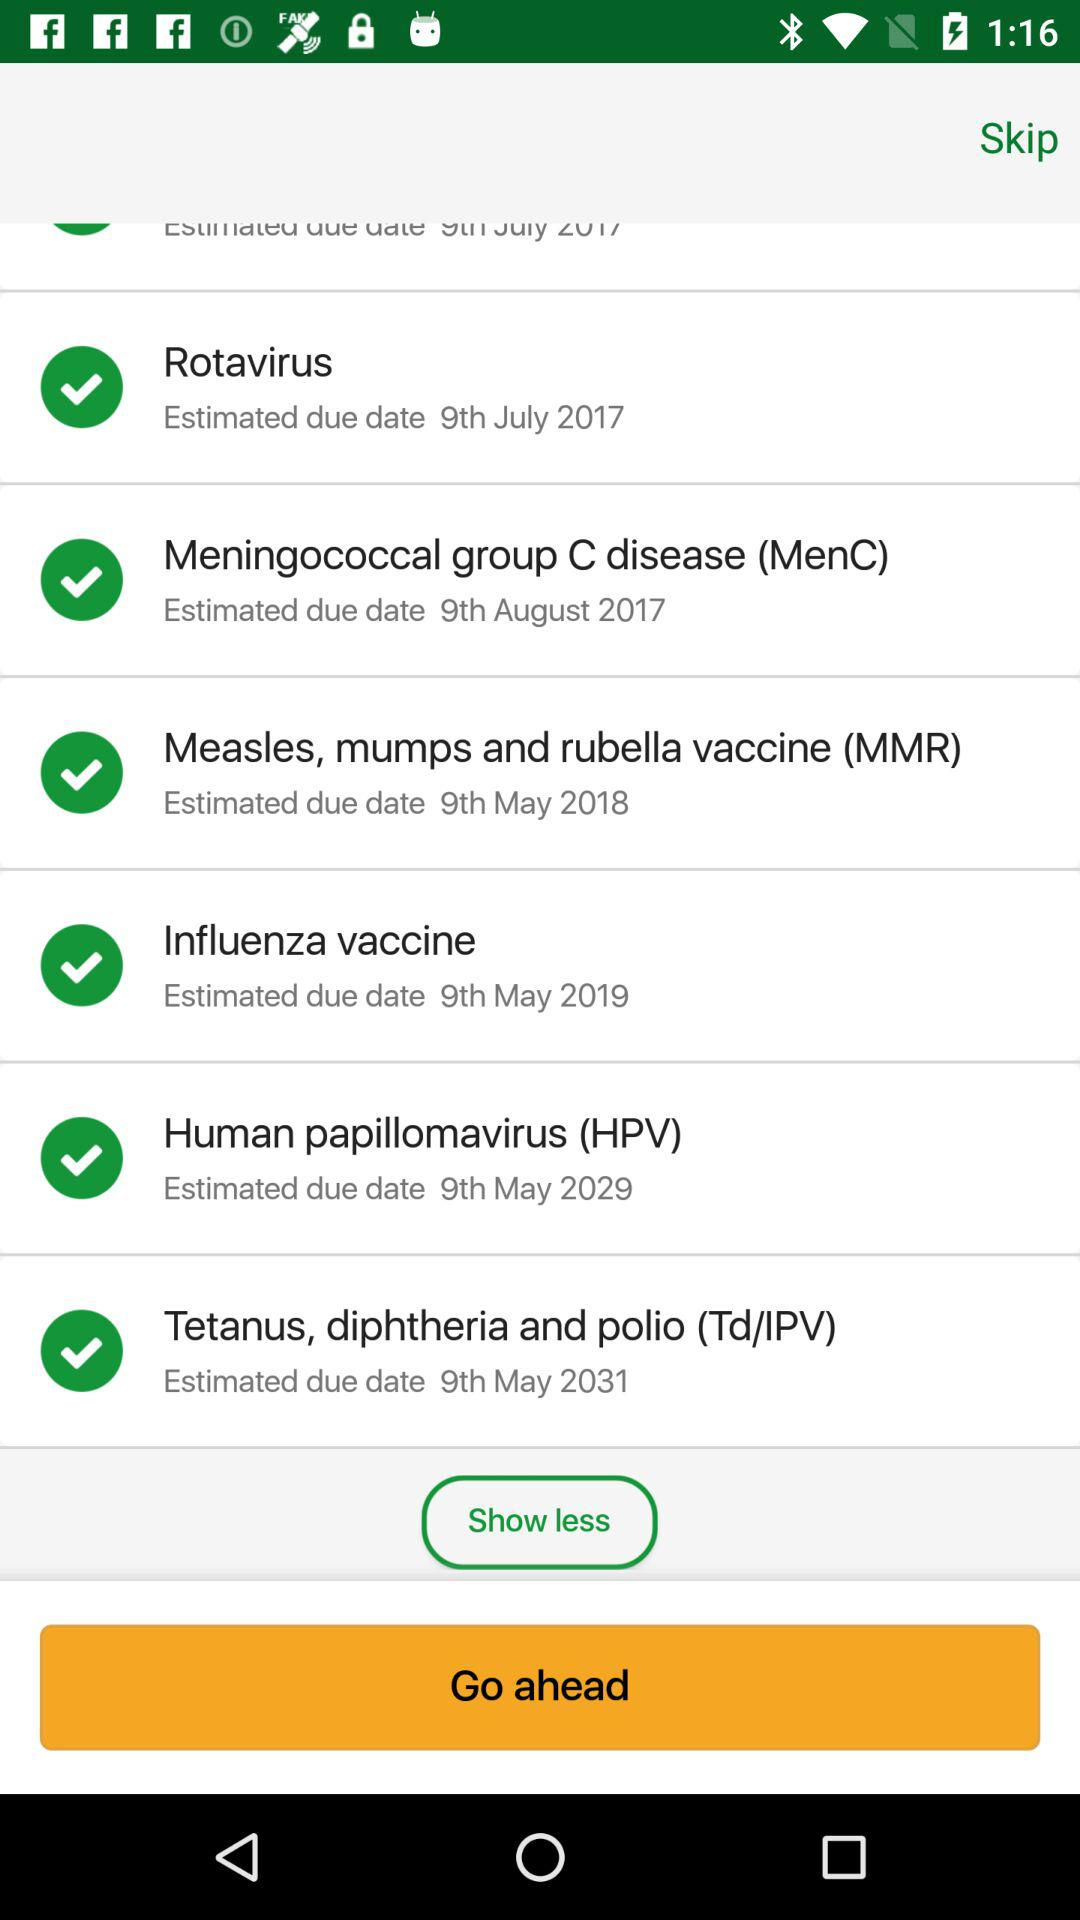Which vaccine's estimated due date is May 9, 2031? The vaccine that has an estimated due date of May 9, 2031 is the "Tetanus, diphtheria and polio (Td/IPV)". 